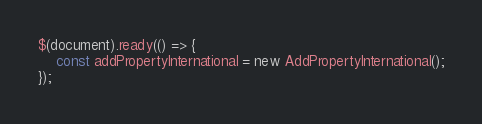<code> <loc_0><loc_0><loc_500><loc_500><_JavaScript_>$(document).ready(() => {
	const addPropertyInternational = new AddPropertyInternational();
});</code> 